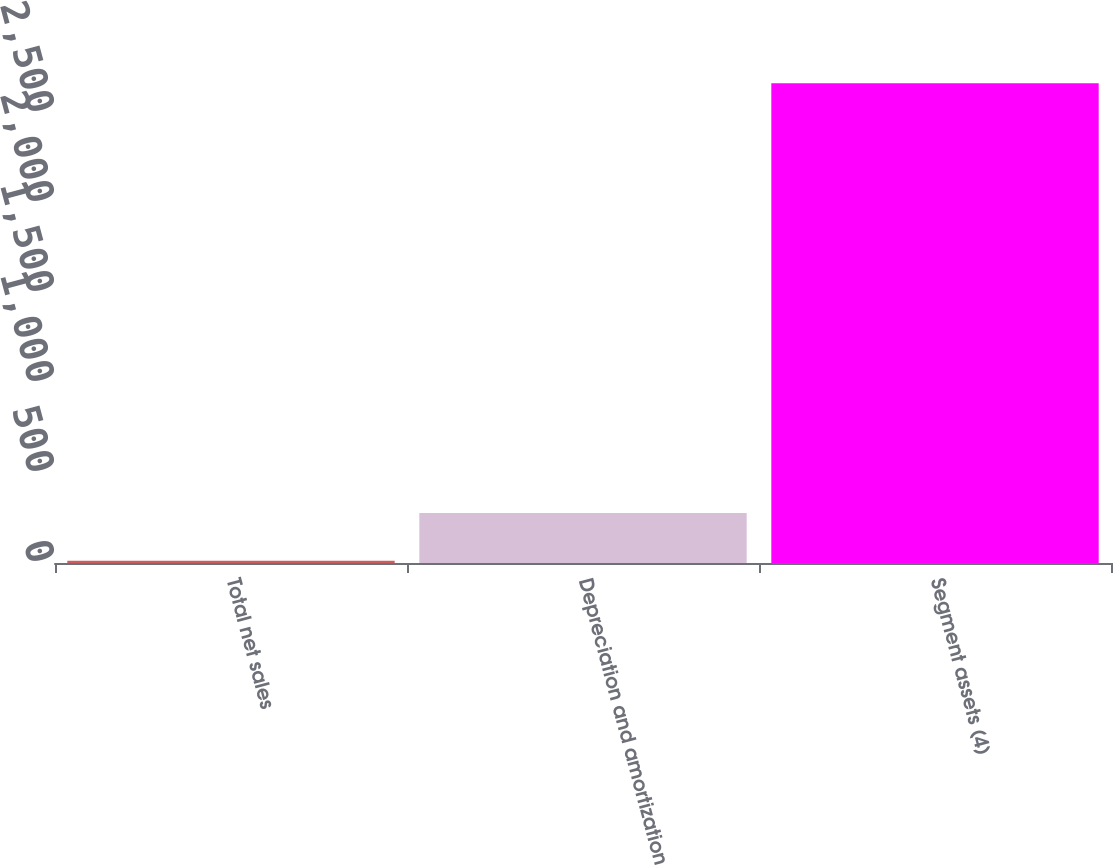<chart> <loc_0><loc_0><loc_500><loc_500><bar_chart><fcel>Total net sales<fcel>Depreciation and amortization<fcel>Segment assets (4)<nl><fcel>12<fcel>277.3<fcel>2665<nl></chart> 